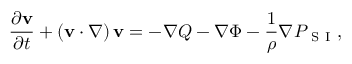Convert formula to latex. <formula><loc_0><loc_0><loc_500><loc_500>\frac { \partial v } { \partial t } + \left ( v \cdot \nabla \right ) v = - \nabla Q - \nabla \Phi - \frac { 1 } { \rho } \nabla P _ { S I } ,</formula> 